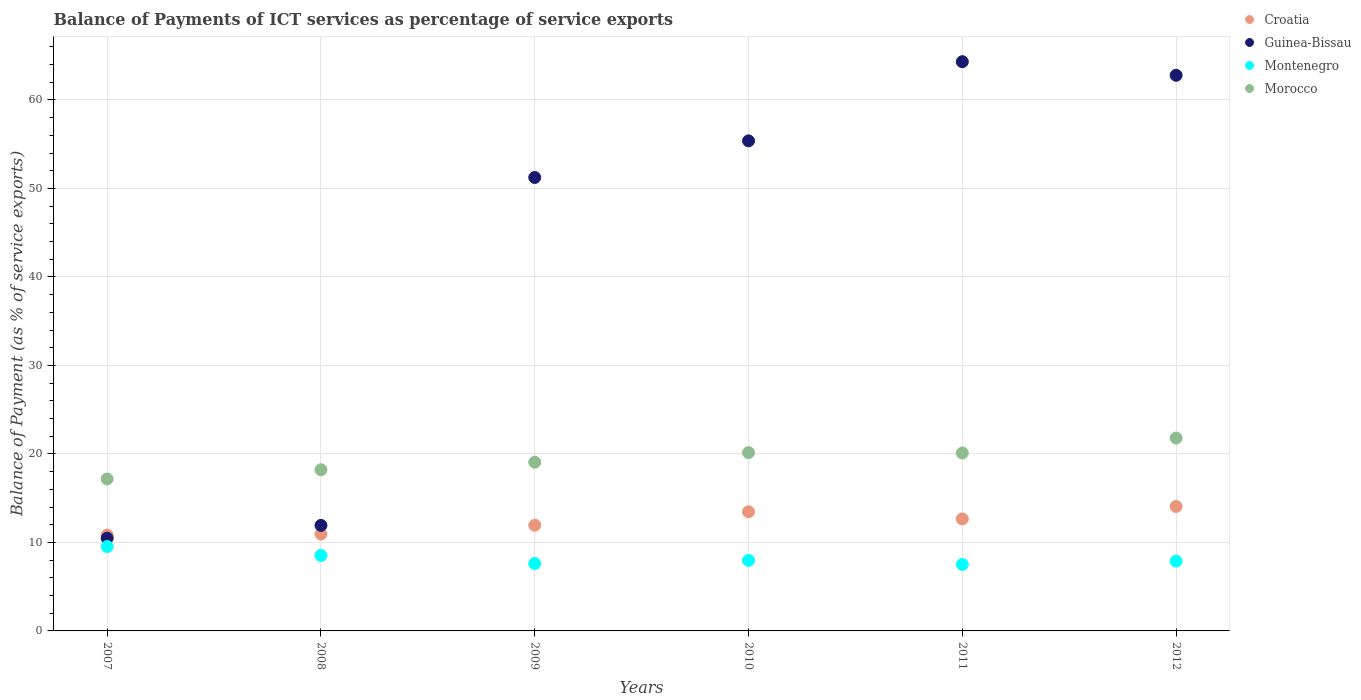Is the number of dotlines equal to the number of legend labels?
Provide a succinct answer. Yes. What is the balance of payments of ICT services in Croatia in 2011?
Give a very brief answer. 12.66. Across all years, what is the maximum balance of payments of ICT services in Guinea-Bissau?
Offer a terse response. 64.32. Across all years, what is the minimum balance of payments of ICT services in Guinea-Bissau?
Keep it short and to the point. 10.48. In which year was the balance of payments of ICT services in Croatia maximum?
Provide a short and direct response. 2012. In which year was the balance of payments of ICT services in Montenegro minimum?
Your response must be concise. 2011. What is the total balance of payments of ICT services in Montenegro in the graph?
Ensure brevity in your answer.  49.05. What is the difference between the balance of payments of ICT services in Croatia in 2007 and that in 2008?
Provide a succinct answer. -0.1. What is the difference between the balance of payments of ICT services in Montenegro in 2011 and the balance of payments of ICT services in Guinea-Bissau in 2007?
Your response must be concise. -2.97. What is the average balance of payments of ICT services in Croatia per year?
Ensure brevity in your answer.  12.32. In the year 2008, what is the difference between the balance of payments of ICT services in Morocco and balance of payments of ICT services in Guinea-Bissau?
Provide a short and direct response. 6.29. In how many years, is the balance of payments of ICT services in Guinea-Bissau greater than 18 %?
Your answer should be compact. 4. What is the ratio of the balance of payments of ICT services in Montenegro in 2007 to that in 2009?
Your response must be concise. 1.25. Is the balance of payments of ICT services in Guinea-Bissau in 2007 less than that in 2010?
Provide a short and direct response. Yes. What is the difference between the highest and the second highest balance of payments of ICT services in Morocco?
Offer a very short reply. 1.65. What is the difference between the highest and the lowest balance of payments of ICT services in Montenegro?
Keep it short and to the point. 2.02. In how many years, is the balance of payments of ICT services in Morocco greater than the average balance of payments of ICT services in Morocco taken over all years?
Make the answer very short. 3. Is it the case that in every year, the sum of the balance of payments of ICT services in Montenegro and balance of payments of ICT services in Morocco  is greater than the balance of payments of ICT services in Guinea-Bissau?
Ensure brevity in your answer.  No. Does the balance of payments of ICT services in Guinea-Bissau monotonically increase over the years?
Offer a very short reply. No. How many dotlines are there?
Offer a very short reply. 4. Does the graph contain grids?
Give a very brief answer. Yes. Where does the legend appear in the graph?
Provide a succinct answer. Top right. How many legend labels are there?
Make the answer very short. 4. How are the legend labels stacked?
Provide a short and direct response. Vertical. What is the title of the graph?
Give a very brief answer. Balance of Payments of ICT services as percentage of service exports. Does "Kenya" appear as one of the legend labels in the graph?
Ensure brevity in your answer.  No. What is the label or title of the X-axis?
Your answer should be very brief. Years. What is the label or title of the Y-axis?
Provide a short and direct response. Balance of Payment (as % of service exports). What is the Balance of Payment (as % of service exports) of Croatia in 2007?
Ensure brevity in your answer.  10.83. What is the Balance of Payment (as % of service exports) in Guinea-Bissau in 2007?
Make the answer very short. 10.48. What is the Balance of Payment (as % of service exports) in Montenegro in 2007?
Offer a very short reply. 9.54. What is the Balance of Payment (as % of service exports) of Morocco in 2007?
Your response must be concise. 17.17. What is the Balance of Payment (as % of service exports) in Croatia in 2008?
Your response must be concise. 10.94. What is the Balance of Payment (as % of service exports) of Guinea-Bissau in 2008?
Keep it short and to the point. 11.93. What is the Balance of Payment (as % of service exports) of Montenegro in 2008?
Provide a short and direct response. 8.53. What is the Balance of Payment (as % of service exports) of Morocco in 2008?
Keep it short and to the point. 18.21. What is the Balance of Payment (as % of service exports) of Croatia in 2009?
Ensure brevity in your answer.  11.94. What is the Balance of Payment (as % of service exports) in Guinea-Bissau in 2009?
Make the answer very short. 51.24. What is the Balance of Payment (as % of service exports) in Montenegro in 2009?
Make the answer very short. 7.62. What is the Balance of Payment (as % of service exports) in Morocco in 2009?
Your answer should be very brief. 19.06. What is the Balance of Payment (as % of service exports) of Croatia in 2010?
Your answer should be very brief. 13.46. What is the Balance of Payment (as % of service exports) in Guinea-Bissau in 2010?
Give a very brief answer. 55.38. What is the Balance of Payment (as % of service exports) in Montenegro in 2010?
Your answer should be compact. 7.97. What is the Balance of Payment (as % of service exports) of Morocco in 2010?
Provide a succinct answer. 20.15. What is the Balance of Payment (as % of service exports) of Croatia in 2011?
Your response must be concise. 12.66. What is the Balance of Payment (as % of service exports) of Guinea-Bissau in 2011?
Offer a terse response. 64.32. What is the Balance of Payment (as % of service exports) of Montenegro in 2011?
Keep it short and to the point. 7.51. What is the Balance of Payment (as % of service exports) of Morocco in 2011?
Provide a short and direct response. 20.11. What is the Balance of Payment (as % of service exports) in Croatia in 2012?
Provide a short and direct response. 14.06. What is the Balance of Payment (as % of service exports) of Guinea-Bissau in 2012?
Your response must be concise. 62.79. What is the Balance of Payment (as % of service exports) in Montenegro in 2012?
Ensure brevity in your answer.  7.88. What is the Balance of Payment (as % of service exports) of Morocco in 2012?
Offer a very short reply. 21.8. Across all years, what is the maximum Balance of Payment (as % of service exports) in Croatia?
Offer a very short reply. 14.06. Across all years, what is the maximum Balance of Payment (as % of service exports) of Guinea-Bissau?
Provide a short and direct response. 64.32. Across all years, what is the maximum Balance of Payment (as % of service exports) of Montenegro?
Keep it short and to the point. 9.54. Across all years, what is the maximum Balance of Payment (as % of service exports) in Morocco?
Provide a short and direct response. 21.8. Across all years, what is the minimum Balance of Payment (as % of service exports) in Croatia?
Offer a very short reply. 10.83. Across all years, what is the minimum Balance of Payment (as % of service exports) of Guinea-Bissau?
Make the answer very short. 10.48. Across all years, what is the minimum Balance of Payment (as % of service exports) of Montenegro?
Ensure brevity in your answer.  7.51. Across all years, what is the minimum Balance of Payment (as % of service exports) of Morocco?
Your response must be concise. 17.17. What is the total Balance of Payment (as % of service exports) of Croatia in the graph?
Make the answer very short. 73.9. What is the total Balance of Payment (as % of service exports) of Guinea-Bissau in the graph?
Make the answer very short. 256.13. What is the total Balance of Payment (as % of service exports) in Montenegro in the graph?
Offer a terse response. 49.05. What is the total Balance of Payment (as % of service exports) in Morocco in the graph?
Your response must be concise. 116.5. What is the difference between the Balance of Payment (as % of service exports) of Croatia in 2007 and that in 2008?
Offer a terse response. -0.1. What is the difference between the Balance of Payment (as % of service exports) of Guinea-Bissau in 2007 and that in 2008?
Make the answer very short. -1.44. What is the difference between the Balance of Payment (as % of service exports) in Morocco in 2007 and that in 2008?
Make the answer very short. -1.04. What is the difference between the Balance of Payment (as % of service exports) in Croatia in 2007 and that in 2009?
Make the answer very short. -1.11. What is the difference between the Balance of Payment (as % of service exports) in Guinea-Bissau in 2007 and that in 2009?
Give a very brief answer. -40.76. What is the difference between the Balance of Payment (as % of service exports) in Montenegro in 2007 and that in 2009?
Your response must be concise. 1.92. What is the difference between the Balance of Payment (as % of service exports) in Morocco in 2007 and that in 2009?
Give a very brief answer. -1.89. What is the difference between the Balance of Payment (as % of service exports) in Croatia in 2007 and that in 2010?
Provide a short and direct response. -2.63. What is the difference between the Balance of Payment (as % of service exports) of Guinea-Bissau in 2007 and that in 2010?
Provide a short and direct response. -44.89. What is the difference between the Balance of Payment (as % of service exports) of Montenegro in 2007 and that in 2010?
Give a very brief answer. 1.57. What is the difference between the Balance of Payment (as % of service exports) in Morocco in 2007 and that in 2010?
Your response must be concise. -2.98. What is the difference between the Balance of Payment (as % of service exports) in Croatia in 2007 and that in 2011?
Give a very brief answer. -1.82. What is the difference between the Balance of Payment (as % of service exports) in Guinea-Bissau in 2007 and that in 2011?
Make the answer very short. -53.84. What is the difference between the Balance of Payment (as % of service exports) of Montenegro in 2007 and that in 2011?
Your answer should be very brief. 2.02. What is the difference between the Balance of Payment (as % of service exports) in Morocco in 2007 and that in 2011?
Keep it short and to the point. -2.94. What is the difference between the Balance of Payment (as % of service exports) of Croatia in 2007 and that in 2012?
Offer a very short reply. -3.23. What is the difference between the Balance of Payment (as % of service exports) of Guinea-Bissau in 2007 and that in 2012?
Your answer should be very brief. -52.3. What is the difference between the Balance of Payment (as % of service exports) of Montenegro in 2007 and that in 2012?
Make the answer very short. 1.65. What is the difference between the Balance of Payment (as % of service exports) of Morocco in 2007 and that in 2012?
Your answer should be compact. -4.63. What is the difference between the Balance of Payment (as % of service exports) in Croatia in 2008 and that in 2009?
Your answer should be compact. -1.01. What is the difference between the Balance of Payment (as % of service exports) of Guinea-Bissau in 2008 and that in 2009?
Keep it short and to the point. -39.31. What is the difference between the Balance of Payment (as % of service exports) in Montenegro in 2008 and that in 2009?
Your answer should be compact. 0.92. What is the difference between the Balance of Payment (as % of service exports) in Morocco in 2008 and that in 2009?
Provide a succinct answer. -0.85. What is the difference between the Balance of Payment (as % of service exports) of Croatia in 2008 and that in 2010?
Make the answer very short. -2.52. What is the difference between the Balance of Payment (as % of service exports) in Guinea-Bissau in 2008 and that in 2010?
Give a very brief answer. -43.45. What is the difference between the Balance of Payment (as % of service exports) in Montenegro in 2008 and that in 2010?
Your response must be concise. 0.56. What is the difference between the Balance of Payment (as % of service exports) in Morocco in 2008 and that in 2010?
Your answer should be very brief. -1.93. What is the difference between the Balance of Payment (as % of service exports) in Croatia in 2008 and that in 2011?
Provide a short and direct response. -1.72. What is the difference between the Balance of Payment (as % of service exports) of Guinea-Bissau in 2008 and that in 2011?
Your answer should be compact. -52.39. What is the difference between the Balance of Payment (as % of service exports) in Montenegro in 2008 and that in 2011?
Your response must be concise. 1.02. What is the difference between the Balance of Payment (as % of service exports) of Morocco in 2008 and that in 2011?
Offer a terse response. -1.89. What is the difference between the Balance of Payment (as % of service exports) in Croatia in 2008 and that in 2012?
Keep it short and to the point. -3.13. What is the difference between the Balance of Payment (as % of service exports) in Guinea-Bissau in 2008 and that in 2012?
Give a very brief answer. -50.86. What is the difference between the Balance of Payment (as % of service exports) of Montenegro in 2008 and that in 2012?
Ensure brevity in your answer.  0.65. What is the difference between the Balance of Payment (as % of service exports) in Morocco in 2008 and that in 2012?
Your answer should be very brief. -3.58. What is the difference between the Balance of Payment (as % of service exports) in Croatia in 2009 and that in 2010?
Provide a succinct answer. -1.52. What is the difference between the Balance of Payment (as % of service exports) in Guinea-Bissau in 2009 and that in 2010?
Offer a terse response. -4.14. What is the difference between the Balance of Payment (as % of service exports) in Montenegro in 2009 and that in 2010?
Your answer should be very brief. -0.35. What is the difference between the Balance of Payment (as % of service exports) in Morocco in 2009 and that in 2010?
Ensure brevity in your answer.  -1.08. What is the difference between the Balance of Payment (as % of service exports) of Croatia in 2009 and that in 2011?
Your answer should be very brief. -0.71. What is the difference between the Balance of Payment (as % of service exports) in Guinea-Bissau in 2009 and that in 2011?
Your response must be concise. -13.08. What is the difference between the Balance of Payment (as % of service exports) of Montenegro in 2009 and that in 2011?
Give a very brief answer. 0.11. What is the difference between the Balance of Payment (as % of service exports) of Morocco in 2009 and that in 2011?
Provide a succinct answer. -1.04. What is the difference between the Balance of Payment (as % of service exports) of Croatia in 2009 and that in 2012?
Offer a terse response. -2.12. What is the difference between the Balance of Payment (as % of service exports) of Guinea-Bissau in 2009 and that in 2012?
Ensure brevity in your answer.  -11.55. What is the difference between the Balance of Payment (as % of service exports) in Montenegro in 2009 and that in 2012?
Give a very brief answer. -0.27. What is the difference between the Balance of Payment (as % of service exports) of Morocco in 2009 and that in 2012?
Your answer should be very brief. -2.73. What is the difference between the Balance of Payment (as % of service exports) in Croatia in 2010 and that in 2011?
Offer a very short reply. 0.81. What is the difference between the Balance of Payment (as % of service exports) in Guinea-Bissau in 2010 and that in 2011?
Ensure brevity in your answer.  -8.94. What is the difference between the Balance of Payment (as % of service exports) of Montenegro in 2010 and that in 2011?
Keep it short and to the point. 0.46. What is the difference between the Balance of Payment (as % of service exports) in Morocco in 2010 and that in 2011?
Keep it short and to the point. 0.04. What is the difference between the Balance of Payment (as % of service exports) in Croatia in 2010 and that in 2012?
Ensure brevity in your answer.  -0.6. What is the difference between the Balance of Payment (as % of service exports) of Guinea-Bissau in 2010 and that in 2012?
Ensure brevity in your answer.  -7.41. What is the difference between the Balance of Payment (as % of service exports) in Montenegro in 2010 and that in 2012?
Offer a very short reply. 0.09. What is the difference between the Balance of Payment (as % of service exports) in Morocco in 2010 and that in 2012?
Ensure brevity in your answer.  -1.65. What is the difference between the Balance of Payment (as % of service exports) in Croatia in 2011 and that in 2012?
Offer a very short reply. -1.41. What is the difference between the Balance of Payment (as % of service exports) of Guinea-Bissau in 2011 and that in 2012?
Your answer should be very brief. 1.53. What is the difference between the Balance of Payment (as % of service exports) in Montenegro in 2011 and that in 2012?
Your answer should be very brief. -0.37. What is the difference between the Balance of Payment (as % of service exports) in Morocco in 2011 and that in 2012?
Your response must be concise. -1.69. What is the difference between the Balance of Payment (as % of service exports) in Croatia in 2007 and the Balance of Payment (as % of service exports) in Guinea-Bissau in 2008?
Keep it short and to the point. -1.09. What is the difference between the Balance of Payment (as % of service exports) in Croatia in 2007 and the Balance of Payment (as % of service exports) in Montenegro in 2008?
Keep it short and to the point. 2.3. What is the difference between the Balance of Payment (as % of service exports) of Croatia in 2007 and the Balance of Payment (as % of service exports) of Morocco in 2008?
Your answer should be very brief. -7.38. What is the difference between the Balance of Payment (as % of service exports) of Guinea-Bissau in 2007 and the Balance of Payment (as % of service exports) of Montenegro in 2008?
Provide a succinct answer. 1.95. What is the difference between the Balance of Payment (as % of service exports) of Guinea-Bissau in 2007 and the Balance of Payment (as % of service exports) of Morocco in 2008?
Provide a succinct answer. -7.73. What is the difference between the Balance of Payment (as % of service exports) in Montenegro in 2007 and the Balance of Payment (as % of service exports) in Morocco in 2008?
Your answer should be compact. -8.68. What is the difference between the Balance of Payment (as % of service exports) of Croatia in 2007 and the Balance of Payment (as % of service exports) of Guinea-Bissau in 2009?
Make the answer very short. -40.4. What is the difference between the Balance of Payment (as % of service exports) in Croatia in 2007 and the Balance of Payment (as % of service exports) in Montenegro in 2009?
Ensure brevity in your answer.  3.22. What is the difference between the Balance of Payment (as % of service exports) in Croatia in 2007 and the Balance of Payment (as % of service exports) in Morocco in 2009?
Offer a very short reply. -8.23. What is the difference between the Balance of Payment (as % of service exports) in Guinea-Bissau in 2007 and the Balance of Payment (as % of service exports) in Montenegro in 2009?
Ensure brevity in your answer.  2.87. What is the difference between the Balance of Payment (as % of service exports) in Guinea-Bissau in 2007 and the Balance of Payment (as % of service exports) in Morocco in 2009?
Give a very brief answer. -8.58. What is the difference between the Balance of Payment (as % of service exports) in Montenegro in 2007 and the Balance of Payment (as % of service exports) in Morocco in 2009?
Your response must be concise. -9.53. What is the difference between the Balance of Payment (as % of service exports) in Croatia in 2007 and the Balance of Payment (as % of service exports) in Guinea-Bissau in 2010?
Offer a terse response. -44.54. What is the difference between the Balance of Payment (as % of service exports) of Croatia in 2007 and the Balance of Payment (as % of service exports) of Montenegro in 2010?
Offer a terse response. 2.86. What is the difference between the Balance of Payment (as % of service exports) of Croatia in 2007 and the Balance of Payment (as % of service exports) of Morocco in 2010?
Keep it short and to the point. -9.31. What is the difference between the Balance of Payment (as % of service exports) of Guinea-Bissau in 2007 and the Balance of Payment (as % of service exports) of Montenegro in 2010?
Give a very brief answer. 2.51. What is the difference between the Balance of Payment (as % of service exports) of Guinea-Bissau in 2007 and the Balance of Payment (as % of service exports) of Morocco in 2010?
Your response must be concise. -9.66. What is the difference between the Balance of Payment (as % of service exports) in Montenegro in 2007 and the Balance of Payment (as % of service exports) in Morocco in 2010?
Your answer should be very brief. -10.61. What is the difference between the Balance of Payment (as % of service exports) in Croatia in 2007 and the Balance of Payment (as % of service exports) in Guinea-Bissau in 2011?
Give a very brief answer. -53.49. What is the difference between the Balance of Payment (as % of service exports) of Croatia in 2007 and the Balance of Payment (as % of service exports) of Montenegro in 2011?
Offer a very short reply. 3.32. What is the difference between the Balance of Payment (as % of service exports) of Croatia in 2007 and the Balance of Payment (as % of service exports) of Morocco in 2011?
Your answer should be very brief. -9.27. What is the difference between the Balance of Payment (as % of service exports) of Guinea-Bissau in 2007 and the Balance of Payment (as % of service exports) of Montenegro in 2011?
Provide a short and direct response. 2.97. What is the difference between the Balance of Payment (as % of service exports) in Guinea-Bissau in 2007 and the Balance of Payment (as % of service exports) in Morocco in 2011?
Make the answer very short. -9.62. What is the difference between the Balance of Payment (as % of service exports) in Montenegro in 2007 and the Balance of Payment (as % of service exports) in Morocco in 2011?
Provide a short and direct response. -10.57. What is the difference between the Balance of Payment (as % of service exports) of Croatia in 2007 and the Balance of Payment (as % of service exports) of Guinea-Bissau in 2012?
Offer a very short reply. -51.95. What is the difference between the Balance of Payment (as % of service exports) in Croatia in 2007 and the Balance of Payment (as % of service exports) in Montenegro in 2012?
Keep it short and to the point. 2.95. What is the difference between the Balance of Payment (as % of service exports) in Croatia in 2007 and the Balance of Payment (as % of service exports) in Morocco in 2012?
Your answer should be compact. -10.96. What is the difference between the Balance of Payment (as % of service exports) in Guinea-Bissau in 2007 and the Balance of Payment (as % of service exports) in Montenegro in 2012?
Provide a short and direct response. 2.6. What is the difference between the Balance of Payment (as % of service exports) in Guinea-Bissau in 2007 and the Balance of Payment (as % of service exports) in Morocco in 2012?
Keep it short and to the point. -11.31. What is the difference between the Balance of Payment (as % of service exports) in Montenegro in 2007 and the Balance of Payment (as % of service exports) in Morocco in 2012?
Make the answer very short. -12.26. What is the difference between the Balance of Payment (as % of service exports) of Croatia in 2008 and the Balance of Payment (as % of service exports) of Guinea-Bissau in 2009?
Your answer should be very brief. -40.3. What is the difference between the Balance of Payment (as % of service exports) of Croatia in 2008 and the Balance of Payment (as % of service exports) of Montenegro in 2009?
Offer a terse response. 3.32. What is the difference between the Balance of Payment (as % of service exports) of Croatia in 2008 and the Balance of Payment (as % of service exports) of Morocco in 2009?
Offer a very short reply. -8.13. What is the difference between the Balance of Payment (as % of service exports) of Guinea-Bissau in 2008 and the Balance of Payment (as % of service exports) of Montenegro in 2009?
Provide a short and direct response. 4.31. What is the difference between the Balance of Payment (as % of service exports) in Guinea-Bissau in 2008 and the Balance of Payment (as % of service exports) in Morocco in 2009?
Ensure brevity in your answer.  -7.14. What is the difference between the Balance of Payment (as % of service exports) of Montenegro in 2008 and the Balance of Payment (as % of service exports) of Morocco in 2009?
Your answer should be very brief. -10.53. What is the difference between the Balance of Payment (as % of service exports) in Croatia in 2008 and the Balance of Payment (as % of service exports) in Guinea-Bissau in 2010?
Offer a very short reply. -44.44. What is the difference between the Balance of Payment (as % of service exports) of Croatia in 2008 and the Balance of Payment (as % of service exports) of Montenegro in 2010?
Ensure brevity in your answer.  2.97. What is the difference between the Balance of Payment (as % of service exports) of Croatia in 2008 and the Balance of Payment (as % of service exports) of Morocco in 2010?
Your response must be concise. -9.21. What is the difference between the Balance of Payment (as % of service exports) in Guinea-Bissau in 2008 and the Balance of Payment (as % of service exports) in Montenegro in 2010?
Provide a succinct answer. 3.96. What is the difference between the Balance of Payment (as % of service exports) of Guinea-Bissau in 2008 and the Balance of Payment (as % of service exports) of Morocco in 2010?
Keep it short and to the point. -8.22. What is the difference between the Balance of Payment (as % of service exports) of Montenegro in 2008 and the Balance of Payment (as % of service exports) of Morocco in 2010?
Your response must be concise. -11.61. What is the difference between the Balance of Payment (as % of service exports) of Croatia in 2008 and the Balance of Payment (as % of service exports) of Guinea-Bissau in 2011?
Make the answer very short. -53.38. What is the difference between the Balance of Payment (as % of service exports) in Croatia in 2008 and the Balance of Payment (as % of service exports) in Montenegro in 2011?
Offer a terse response. 3.43. What is the difference between the Balance of Payment (as % of service exports) in Croatia in 2008 and the Balance of Payment (as % of service exports) in Morocco in 2011?
Offer a very short reply. -9.17. What is the difference between the Balance of Payment (as % of service exports) in Guinea-Bissau in 2008 and the Balance of Payment (as % of service exports) in Montenegro in 2011?
Your answer should be compact. 4.42. What is the difference between the Balance of Payment (as % of service exports) of Guinea-Bissau in 2008 and the Balance of Payment (as % of service exports) of Morocco in 2011?
Your answer should be compact. -8.18. What is the difference between the Balance of Payment (as % of service exports) of Montenegro in 2008 and the Balance of Payment (as % of service exports) of Morocco in 2011?
Your answer should be compact. -11.58. What is the difference between the Balance of Payment (as % of service exports) in Croatia in 2008 and the Balance of Payment (as % of service exports) in Guinea-Bissau in 2012?
Your answer should be very brief. -51.85. What is the difference between the Balance of Payment (as % of service exports) in Croatia in 2008 and the Balance of Payment (as % of service exports) in Montenegro in 2012?
Your response must be concise. 3.05. What is the difference between the Balance of Payment (as % of service exports) of Croatia in 2008 and the Balance of Payment (as % of service exports) of Morocco in 2012?
Provide a succinct answer. -10.86. What is the difference between the Balance of Payment (as % of service exports) of Guinea-Bissau in 2008 and the Balance of Payment (as % of service exports) of Montenegro in 2012?
Make the answer very short. 4.04. What is the difference between the Balance of Payment (as % of service exports) in Guinea-Bissau in 2008 and the Balance of Payment (as % of service exports) in Morocco in 2012?
Provide a short and direct response. -9.87. What is the difference between the Balance of Payment (as % of service exports) of Montenegro in 2008 and the Balance of Payment (as % of service exports) of Morocco in 2012?
Your answer should be very brief. -13.26. What is the difference between the Balance of Payment (as % of service exports) of Croatia in 2009 and the Balance of Payment (as % of service exports) of Guinea-Bissau in 2010?
Give a very brief answer. -43.43. What is the difference between the Balance of Payment (as % of service exports) of Croatia in 2009 and the Balance of Payment (as % of service exports) of Montenegro in 2010?
Keep it short and to the point. 3.97. What is the difference between the Balance of Payment (as % of service exports) in Croatia in 2009 and the Balance of Payment (as % of service exports) in Morocco in 2010?
Give a very brief answer. -8.2. What is the difference between the Balance of Payment (as % of service exports) in Guinea-Bissau in 2009 and the Balance of Payment (as % of service exports) in Montenegro in 2010?
Offer a very short reply. 43.27. What is the difference between the Balance of Payment (as % of service exports) of Guinea-Bissau in 2009 and the Balance of Payment (as % of service exports) of Morocco in 2010?
Ensure brevity in your answer.  31.09. What is the difference between the Balance of Payment (as % of service exports) of Montenegro in 2009 and the Balance of Payment (as % of service exports) of Morocco in 2010?
Your answer should be very brief. -12.53. What is the difference between the Balance of Payment (as % of service exports) in Croatia in 2009 and the Balance of Payment (as % of service exports) in Guinea-Bissau in 2011?
Your answer should be very brief. -52.38. What is the difference between the Balance of Payment (as % of service exports) in Croatia in 2009 and the Balance of Payment (as % of service exports) in Montenegro in 2011?
Keep it short and to the point. 4.43. What is the difference between the Balance of Payment (as % of service exports) in Croatia in 2009 and the Balance of Payment (as % of service exports) in Morocco in 2011?
Offer a terse response. -8.16. What is the difference between the Balance of Payment (as % of service exports) in Guinea-Bissau in 2009 and the Balance of Payment (as % of service exports) in Montenegro in 2011?
Provide a succinct answer. 43.73. What is the difference between the Balance of Payment (as % of service exports) of Guinea-Bissau in 2009 and the Balance of Payment (as % of service exports) of Morocco in 2011?
Provide a short and direct response. 31.13. What is the difference between the Balance of Payment (as % of service exports) in Montenegro in 2009 and the Balance of Payment (as % of service exports) in Morocco in 2011?
Give a very brief answer. -12.49. What is the difference between the Balance of Payment (as % of service exports) of Croatia in 2009 and the Balance of Payment (as % of service exports) of Guinea-Bissau in 2012?
Provide a short and direct response. -50.84. What is the difference between the Balance of Payment (as % of service exports) in Croatia in 2009 and the Balance of Payment (as % of service exports) in Montenegro in 2012?
Ensure brevity in your answer.  4.06. What is the difference between the Balance of Payment (as % of service exports) of Croatia in 2009 and the Balance of Payment (as % of service exports) of Morocco in 2012?
Keep it short and to the point. -9.85. What is the difference between the Balance of Payment (as % of service exports) in Guinea-Bissau in 2009 and the Balance of Payment (as % of service exports) in Montenegro in 2012?
Offer a very short reply. 43.35. What is the difference between the Balance of Payment (as % of service exports) in Guinea-Bissau in 2009 and the Balance of Payment (as % of service exports) in Morocco in 2012?
Your answer should be very brief. 29.44. What is the difference between the Balance of Payment (as % of service exports) of Montenegro in 2009 and the Balance of Payment (as % of service exports) of Morocco in 2012?
Ensure brevity in your answer.  -14.18. What is the difference between the Balance of Payment (as % of service exports) of Croatia in 2010 and the Balance of Payment (as % of service exports) of Guinea-Bissau in 2011?
Offer a terse response. -50.86. What is the difference between the Balance of Payment (as % of service exports) of Croatia in 2010 and the Balance of Payment (as % of service exports) of Montenegro in 2011?
Ensure brevity in your answer.  5.95. What is the difference between the Balance of Payment (as % of service exports) in Croatia in 2010 and the Balance of Payment (as % of service exports) in Morocco in 2011?
Make the answer very short. -6.65. What is the difference between the Balance of Payment (as % of service exports) in Guinea-Bissau in 2010 and the Balance of Payment (as % of service exports) in Montenegro in 2011?
Offer a very short reply. 47.87. What is the difference between the Balance of Payment (as % of service exports) of Guinea-Bissau in 2010 and the Balance of Payment (as % of service exports) of Morocco in 2011?
Offer a terse response. 35.27. What is the difference between the Balance of Payment (as % of service exports) in Montenegro in 2010 and the Balance of Payment (as % of service exports) in Morocco in 2011?
Offer a terse response. -12.14. What is the difference between the Balance of Payment (as % of service exports) of Croatia in 2010 and the Balance of Payment (as % of service exports) of Guinea-Bissau in 2012?
Offer a very short reply. -49.32. What is the difference between the Balance of Payment (as % of service exports) in Croatia in 2010 and the Balance of Payment (as % of service exports) in Montenegro in 2012?
Give a very brief answer. 5.58. What is the difference between the Balance of Payment (as % of service exports) in Croatia in 2010 and the Balance of Payment (as % of service exports) in Morocco in 2012?
Provide a succinct answer. -8.33. What is the difference between the Balance of Payment (as % of service exports) of Guinea-Bissau in 2010 and the Balance of Payment (as % of service exports) of Montenegro in 2012?
Provide a succinct answer. 47.49. What is the difference between the Balance of Payment (as % of service exports) in Guinea-Bissau in 2010 and the Balance of Payment (as % of service exports) in Morocco in 2012?
Your answer should be compact. 33.58. What is the difference between the Balance of Payment (as % of service exports) in Montenegro in 2010 and the Balance of Payment (as % of service exports) in Morocco in 2012?
Offer a very short reply. -13.83. What is the difference between the Balance of Payment (as % of service exports) of Croatia in 2011 and the Balance of Payment (as % of service exports) of Guinea-Bissau in 2012?
Provide a short and direct response. -50.13. What is the difference between the Balance of Payment (as % of service exports) in Croatia in 2011 and the Balance of Payment (as % of service exports) in Montenegro in 2012?
Provide a succinct answer. 4.77. What is the difference between the Balance of Payment (as % of service exports) in Croatia in 2011 and the Balance of Payment (as % of service exports) in Morocco in 2012?
Provide a short and direct response. -9.14. What is the difference between the Balance of Payment (as % of service exports) of Guinea-Bissau in 2011 and the Balance of Payment (as % of service exports) of Montenegro in 2012?
Your response must be concise. 56.44. What is the difference between the Balance of Payment (as % of service exports) of Guinea-Bissau in 2011 and the Balance of Payment (as % of service exports) of Morocco in 2012?
Keep it short and to the point. 42.52. What is the difference between the Balance of Payment (as % of service exports) in Montenegro in 2011 and the Balance of Payment (as % of service exports) in Morocco in 2012?
Your answer should be compact. -14.29. What is the average Balance of Payment (as % of service exports) of Croatia per year?
Provide a short and direct response. 12.32. What is the average Balance of Payment (as % of service exports) in Guinea-Bissau per year?
Your answer should be very brief. 42.69. What is the average Balance of Payment (as % of service exports) in Montenegro per year?
Keep it short and to the point. 8.17. What is the average Balance of Payment (as % of service exports) of Morocco per year?
Provide a succinct answer. 19.42. In the year 2007, what is the difference between the Balance of Payment (as % of service exports) in Croatia and Balance of Payment (as % of service exports) in Guinea-Bissau?
Offer a very short reply. 0.35. In the year 2007, what is the difference between the Balance of Payment (as % of service exports) of Croatia and Balance of Payment (as % of service exports) of Montenegro?
Make the answer very short. 1.3. In the year 2007, what is the difference between the Balance of Payment (as % of service exports) of Croatia and Balance of Payment (as % of service exports) of Morocco?
Ensure brevity in your answer.  -6.34. In the year 2007, what is the difference between the Balance of Payment (as % of service exports) in Guinea-Bissau and Balance of Payment (as % of service exports) in Montenegro?
Provide a short and direct response. 0.95. In the year 2007, what is the difference between the Balance of Payment (as % of service exports) of Guinea-Bissau and Balance of Payment (as % of service exports) of Morocco?
Keep it short and to the point. -6.69. In the year 2007, what is the difference between the Balance of Payment (as % of service exports) in Montenegro and Balance of Payment (as % of service exports) in Morocco?
Offer a terse response. -7.63. In the year 2008, what is the difference between the Balance of Payment (as % of service exports) of Croatia and Balance of Payment (as % of service exports) of Guinea-Bissau?
Make the answer very short. -0.99. In the year 2008, what is the difference between the Balance of Payment (as % of service exports) of Croatia and Balance of Payment (as % of service exports) of Montenegro?
Make the answer very short. 2.41. In the year 2008, what is the difference between the Balance of Payment (as % of service exports) in Croatia and Balance of Payment (as % of service exports) in Morocco?
Give a very brief answer. -7.28. In the year 2008, what is the difference between the Balance of Payment (as % of service exports) in Guinea-Bissau and Balance of Payment (as % of service exports) in Montenegro?
Your answer should be very brief. 3.39. In the year 2008, what is the difference between the Balance of Payment (as % of service exports) of Guinea-Bissau and Balance of Payment (as % of service exports) of Morocco?
Ensure brevity in your answer.  -6.29. In the year 2008, what is the difference between the Balance of Payment (as % of service exports) in Montenegro and Balance of Payment (as % of service exports) in Morocco?
Provide a succinct answer. -9.68. In the year 2009, what is the difference between the Balance of Payment (as % of service exports) in Croatia and Balance of Payment (as % of service exports) in Guinea-Bissau?
Provide a short and direct response. -39.29. In the year 2009, what is the difference between the Balance of Payment (as % of service exports) of Croatia and Balance of Payment (as % of service exports) of Montenegro?
Offer a terse response. 4.33. In the year 2009, what is the difference between the Balance of Payment (as % of service exports) in Croatia and Balance of Payment (as % of service exports) in Morocco?
Your response must be concise. -7.12. In the year 2009, what is the difference between the Balance of Payment (as % of service exports) of Guinea-Bissau and Balance of Payment (as % of service exports) of Montenegro?
Offer a very short reply. 43.62. In the year 2009, what is the difference between the Balance of Payment (as % of service exports) in Guinea-Bissau and Balance of Payment (as % of service exports) in Morocco?
Provide a short and direct response. 32.17. In the year 2009, what is the difference between the Balance of Payment (as % of service exports) of Montenegro and Balance of Payment (as % of service exports) of Morocco?
Offer a terse response. -11.45. In the year 2010, what is the difference between the Balance of Payment (as % of service exports) of Croatia and Balance of Payment (as % of service exports) of Guinea-Bissau?
Keep it short and to the point. -41.91. In the year 2010, what is the difference between the Balance of Payment (as % of service exports) of Croatia and Balance of Payment (as % of service exports) of Montenegro?
Provide a short and direct response. 5.49. In the year 2010, what is the difference between the Balance of Payment (as % of service exports) of Croatia and Balance of Payment (as % of service exports) of Morocco?
Offer a very short reply. -6.68. In the year 2010, what is the difference between the Balance of Payment (as % of service exports) in Guinea-Bissau and Balance of Payment (as % of service exports) in Montenegro?
Your answer should be compact. 47.41. In the year 2010, what is the difference between the Balance of Payment (as % of service exports) of Guinea-Bissau and Balance of Payment (as % of service exports) of Morocco?
Your answer should be compact. 35.23. In the year 2010, what is the difference between the Balance of Payment (as % of service exports) in Montenegro and Balance of Payment (as % of service exports) in Morocco?
Keep it short and to the point. -12.18. In the year 2011, what is the difference between the Balance of Payment (as % of service exports) of Croatia and Balance of Payment (as % of service exports) of Guinea-Bissau?
Offer a terse response. -51.66. In the year 2011, what is the difference between the Balance of Payment (as % of service exports) of Croatia and Balance of Payment (as % of service exports) of Montenegro?
Give a very brief answer. 5.14. In the year 2011, what is the difference between the Balance of Payment (as % of service exports) in Croatia and Balance of Payment (as % of service exports) in Morocco?
Keep it short and to the point. -7.45. In the year 2011, what is the difference between the Balance of Payment (as % of service exports) in Guinea-Bissau and Balance of Payment (as % of service exports) in Montenegro?
Offer a very short reply. 56.81. In the year 2011, what is the difference between the Balance of Payment (as % of service exports) of Guinea-Bissau and Balance of Payment (as % of service exports) of Morocco?
Provide a succinct answer. 44.21. In the year 2011, what is the difference between the Balance of Payment (as % of service exports) in Montenegro and Balance of Payment (as % of service exports) in Morocco?
Provide a short and direct response. -12.6. In the year 2012, what is the difference between the Balance of Payment (as % of service exports) of Croatia and Balance of Payment (as % of service exports) of Guinea-Bissau?
Ensure brevity in your answer.  -48.72. In the year 2012, what is the difference between the Balance of Payment (as % of service exports) of Croatia and Balance of Payment (as % of service exports) of Montenegro?
Offer a terse response. 6.18. In the year 2012, what is the difference between the Balance of Payment (as % of service exports) in Croatia and Balance of Payment (as % of service exports) in Morocco?
Provide a succinct answer. -7.73. In the year 2012, what is the difference between the Balance of Payment (as % of service exports) of Guinea-Bissau and Balance of Payment (as % of service exports) of Montenegro?
Provide a succinct answer. 54.9. In the year 2012, what is the difference between the Balance of Payment (as % of service exports) in Guinea-Bissau and Balance of Payment (as % of service exports) in Morocco?
Your response must be concise. 40.99. In the year 2012, what is the difference between the Balance of Payment (as % of service exports) in Montenegro and Balance of Payment (as % of service exports) in Morocco?
Keep it short and to the point. -13.91. What is the ratio of the Balance of Payment (as % of service exports) of Guinea-Bissau in 2007 to that in 2008?
Your answer should be very brief. 0.88. What is the ratio of the Balance of Payment (as % of service exports) in Montenegro in 2007 to that in 2008?
Keep it short and to the point. 1.12. What is the ratio of the Balance of Payment (as % of service exports) of Morocco in 2007 to that in 2008?
Make the answer very short. 0.94. What is the ratio of the Balance of Payment (as % of service exports) of Croatia in 2007 to that in 2009?
Provide a short and direct response. 0.91. What is the ratio of the Balance of Payment (as % of service exports) of Guinea-Bissau in 2007 to that in 2009?
Your answer should be compact. 0.2. What is the ratio of the Balance of Payment (as % of service exports) of Montenegro in 2007 to that in 2009?
Offer a very short reply. 1.25. What is the ratio of the Balance of Payment (as % of service exports) of Morocco in 2007 to that in 2009?
Your response must be concise. 0.9. What is the ratio of the Balance of Payment (as % of service exports) of Croatia in 2007 to that in 2010?
Offer a terse response. 0.8. What is the ratio of the Balance of Payment (as % of service exports) of Guinea-Bissau in 2007 to that in 2010?
Offer a terse response. 0.19. What is the ratio of the Balance of Payment (as % of service exports) in Montenegro in 2007 to that in 2010?
Provide a short and direct response. 1.2. What is the ratio of the Balance of Payment (as % of service exports) of Morocco in 2007 to that in 2010?
Offer a very short reply. 0.85. What is the ratio of the Balance of Payment (as % of service exports) of Croatia in 2007 to that in 2011?
Your answer should be compact. 0.86. What is the ratio of the Balance of Payment (as % of service exports) of Guinea-Bissau in 2007 to that in 2011?
Your response must be concise. 0.16. What is the ratio of the Balance of Payment (as % of service exports) in Montenegro in 2007 to that in 2011?
Make the answer very short. 1.27. What is the ratio of the Balance of Payment (as % of service exports) in Morocco in 2007 to that in 2011?
Your response must be concise. 0.85. What is the ratio of the Balance of Payment (as % of service exports) in Croatia in 2007 to that in 2012?
Keep it short and to the point. 0.77. What is the ratio of the Balance of Payment (as % of service exports) in Guinea-Bissau in 2007 to that in 2012?
Provide a short and direct response. 0.17. What is the ratio of the Balance of Payment (as % of service exports) in Montenegro in 2007 to that in 2012?
Your response must be concise. 1.21. What is the ratio of the Balance of Payment (as % of service exports) of Morocco in 2007 to that in 2012?
Your answer should be very brief. 0.79. What is the ratio of the Balance of Payment (as % of service exports) in Croatia in 2008 to that in 2009?
Keep it short and to the point. 0.92. What is the ratio of the Balance of Payment (as % of service exports) of Guinea-Bissau in 2008 to that in 2009?
Your response must be concise. 0.23. What is the ratio of the Balance of Payment (as % of service exports) in Montenegro in 2008 to that in 2009?
Your answer should be very brief. 1.12. What is the ratio of the Balance of Payment (as % of service exports) in Morocco in 2008 to that in 2009?
Your answer should be very brief. 0.96. What is the ratio of the Balance of Payment (as % of service exports) of Croatia in 2008 to that in 2010?
Give a very brief answer. 0.81. What is the ratio of the Balance of Payment (as % of service exports) in Guinea-Bissau in 2008 to that in 2010?
Your answer should be very brief. 0.22. What is the ratio of the Balance of Payment (as % of service exports) in Montenegro in 2008 to that in 2010?
Keep it short and to the point. 1.07. What is the ratio of the Balance of Payment (as % of service exports) of Morocco in 2008 to that in 2010?
Your response must be concise. 0.9. What is the ratio of the Balance of Payment (as % of service exports) of Croatia in 2008 to that in 2011?
Offer a terse response. 0.86. What is the ratio of the Balance of Payment (as % of service exports) in Guinea-Bissau in 2008 to that in 2011?
Your response must be concise. 0.19. What is the ratio of the Balance of Payment (as % of service exports) of Montenegro in 2008 to that in 2011?
Your response must be concise. 1.14. What is the ratio of the Balance of Payment (as % of service exports) of Morocco in 2008 to that in 2011?
Provide a short and direct response. 0.91. What is the ratio of the Balance of Payment (as % of service exports) of Croatia in 2008 to that in 2012?
Make the answer very short. 0.78. What is the ratio of the Balance of Payment (as % of service exports) of Guinea-Bissau in 2008 to that in 2012?
Provide a succinct answer. 0.19. What is the ratio of the Balance of Payment (as % of service exports) in Montenegro in 2008 to that in 2012?
Keep it short and to the point. 1.08. What is the ratio of the Balance of Payment (as % of service exports) of Morocco in 2008 to that in 2012?
Provide a short and direct response. 0.84. What is the ratio of the Balance of Payment (as % of service exports) in Croatia in 2009 to that in 2010?
Your response must be concise. 0.89. What is the ratio of the Balance of Payment (as % of service exports) of Guinea-Bissau in 2009 to that in 2010?
Your answer should be very brief. 0.93. What is the ratio of the Balance of Payment (as % of service exports) of Montenegro in 2009 to that in 2010?
Provide a short and direct response. 0.96. What is the ratio of the Balance of Payment (as % of service exports) in Morocco in 2009 to that in 2010?
Offer a very short reply. 0.95. What is the ratio of the Balance of Payment (as % of service exports) of Croatia in 2009 to that in 2011?
Offer a terse response. 0.94. What is the ratio of the Balance of Payment (as % of service exports) in Guinea-Bissau in 2009 to that in 2011?
Offer a very short reply. 0.8. What is the ratio of the Balance of Payment (as % of service exports) of Morocco in 2009 to that in 2011?
Offer a terse response. 0.95. What is the ratio of the Balance of Payment (as % of service exports) of Croatia in 2009 to that in 2012?
Provide a succinct answer. 0.85. What is the ratio of the Balance of Payment (as % of service exports) of Guinea-Bissau in 2009 to that in 2012?
Give a very brief answer. 0.82. What is the ratio of the Balance of Payment (as % of service exports) in Montenegro in 2009 to that in 2012?
Your answer should be compact. 0.97. What is the ratio of the Balance of Payment (as % of service exports) of Morocco in 2009 to that in 2012?
Offer a very short reply. 0.87. What is the ratio of the Balance of Payment (as % of service exports) in Croatia in 2010 to that in 2011?
Make the answer very short. 1.06. What is the ratio of the Balance of Payment (as % of service exports) in Guinea-Bissau in 2010 to that in 2011?
Make the answer very short. 0.86. What is the ratio of the Balance of Payment (as % of service exports) of Montenegro in 2010 to that in 2011?
Make the answer very short. 1.06. What is the ratio of the Balance of Payment (as % of service exports) in Morocco in 2010 to that in 2011?
Provide a succinct answer. 1. What is the ratio of the Balance of Payment (as % of service exports) of Croatia in 2010 to that in 2012?
Your response must be concise. 0.96. What is the ratio of the Balance of Payment (as % of service exports) in Guinea-Bissau in 2010 to that in 2012?
Your response must be concise. 0.88. What is the ratio of the Balance of Payment (as % of service exports) in Montenegro in 2010 to that in 2012?
Provide a short and direct response. 1.01. What is the ratio of the Balance of Payment (as % of service exports) in Morocco in 2010 to that in 2012?
Your answer should be very brief. 0.92. What is the ratio of the Balance of Payment (as % of service exports) in Croatia in 2011 to that in 2012?
Give a very brief answer. 0.9. What is the ratio of the Balance of Payment (as % of service exports) in Guinea-Bissau in 2011 to that in 2012?
Give a very brief answer. 1.02. What is the ratio of the Balance of Payment (as % of service exports) of Montenegro in 2011 to that in 2012?
Keep it short and to the point. 0.95. What is the ratio of the Balance of Payment (as % of service exports) of Morocco in 2011 to that in 2012?
Your response must be concise. 0.92. What is the difference between the highest and the second highest Balance of Payment (as % of service exports) of Croatia?
Give a very brief answer. 0.6. What is the difference between the highest and the second highest Balance of Payment (as % of service exports) in Guinea-Bissau?
Make the answer very short. 1.53. What is the difference between the highest and the second highest Balance of Payment (as % of service exports) of Montenegro?
Ensure brevity in your answer.  1. What is the difference between the highest and the second highest Balance of Payment (as % of service exports) of Morocco?
Your answer should be very brief. 1.65. What is the difference between the highest and the lowest Balance of Payment (as % of service exports) of Croatia?
Offer a terse response. 3.23. What is the difference between the highest and the lowest Balance of Payment (as % of service exports) of Guinea-Bissau?
Ensure brevity in your answer.  53.84. What is the difference between the highest and the lowest Balance of Payment (as % of service exports) of Montenegro?
Offer a terse response. 2.02. What is the difference between the highest and the lowest Balance of Payment (as % of service exports) of Morocco?
Ensure brevity in your answer.  4.63. 